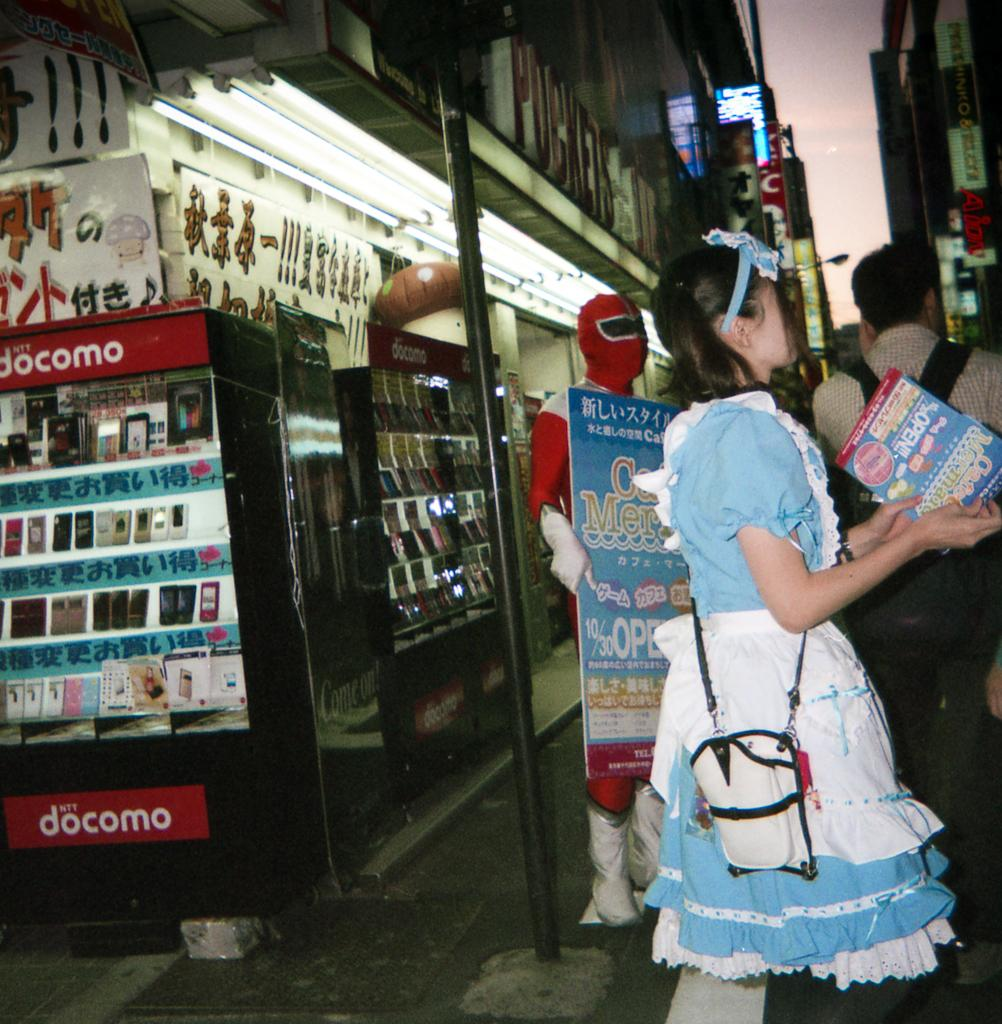<image>
Give a short and clear explanation of the subsequent image. A woman dressed as Dorothy and a Red Power Ranger next to a Docomo stand. 